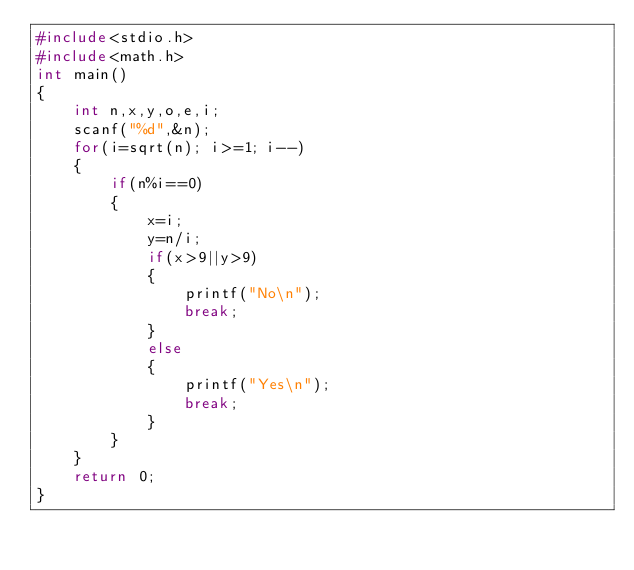<code> <loc_0><loc_0><loc_500><loc_500><_C_>#include<stdio.h>
#include<math.h>
int main()
{
    int n,x,y,o,e,i;
    scanf("%d",&n);
    for(i=sqrt(n); i>=1; i--)
    {
        if(n%i==0)
        {
            x=i;
            y=n/i;
            if(x>9||y>9)
            {
                printf("No\n");
                break;
            }
            else
            {
                printf("Yes\n");
                break;
            }
        }
    }
    return 0;
}
</code> 